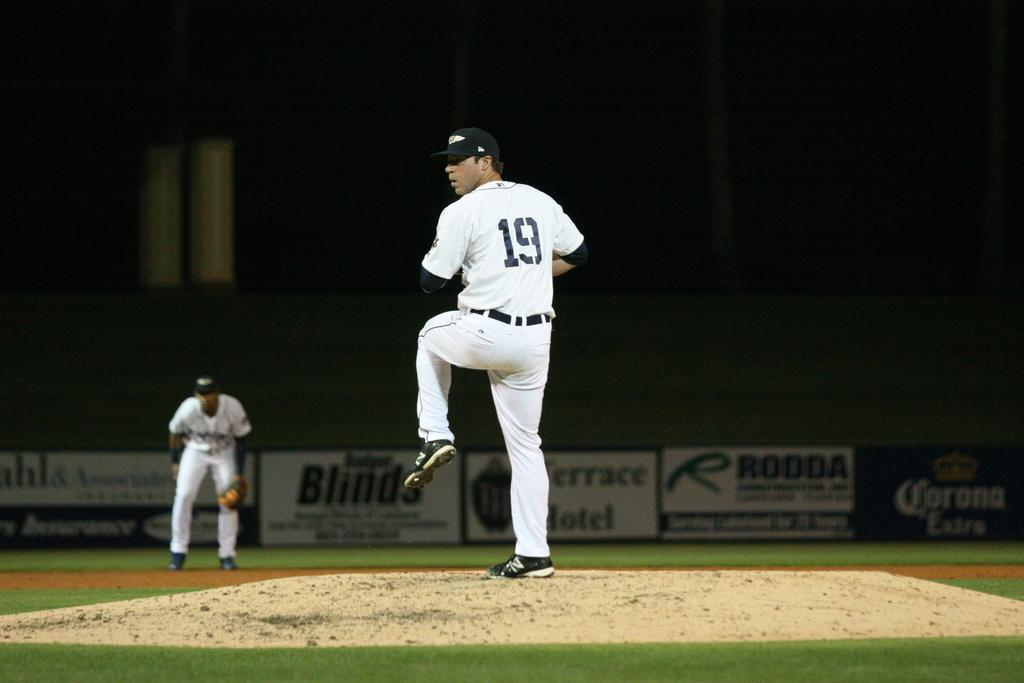<image>
Describe the image concisely. A baseball pitcher with the number 19 sewn into his jersey preparing to throw a ball. 